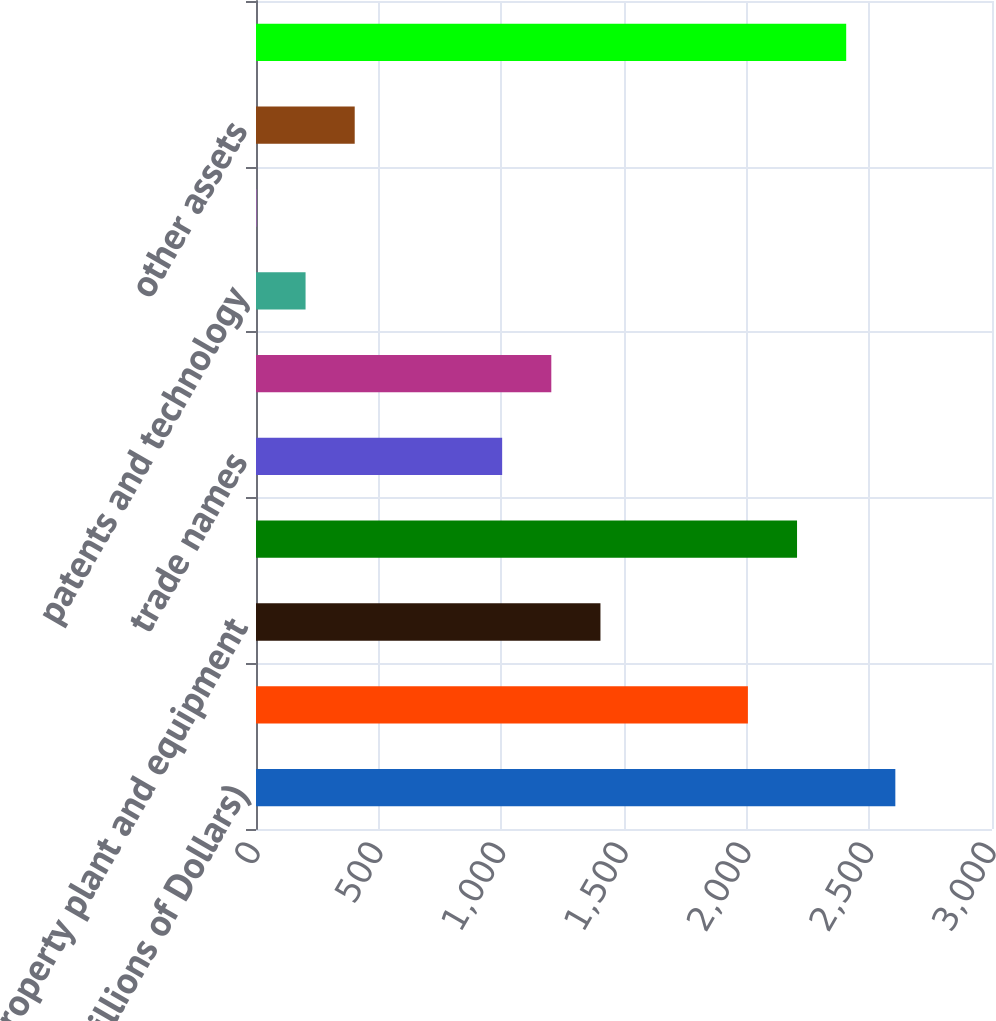Convert chart. <chart><loc_0><loc_0><loc_500><loc_500><bar_chart><fcel>(Millions of Dollars)<fcel>Current assets primarily<fcel>property plant and equipment<fcel>Goodwill<fcel>trade names<fcel>Customer relationships<fcel>patents and technology<fcel>other intangible assets<fcel>other assets<fcel>total assets<nl><fcel>2605.99<fcel>2005<fcel>1404.01<fcel>2205.33<fcel>1003.35<fcel>1203.68<fcel>202.03<fcel>1.7<fcel>402.36<fcel>2405.66<nl></chart> 